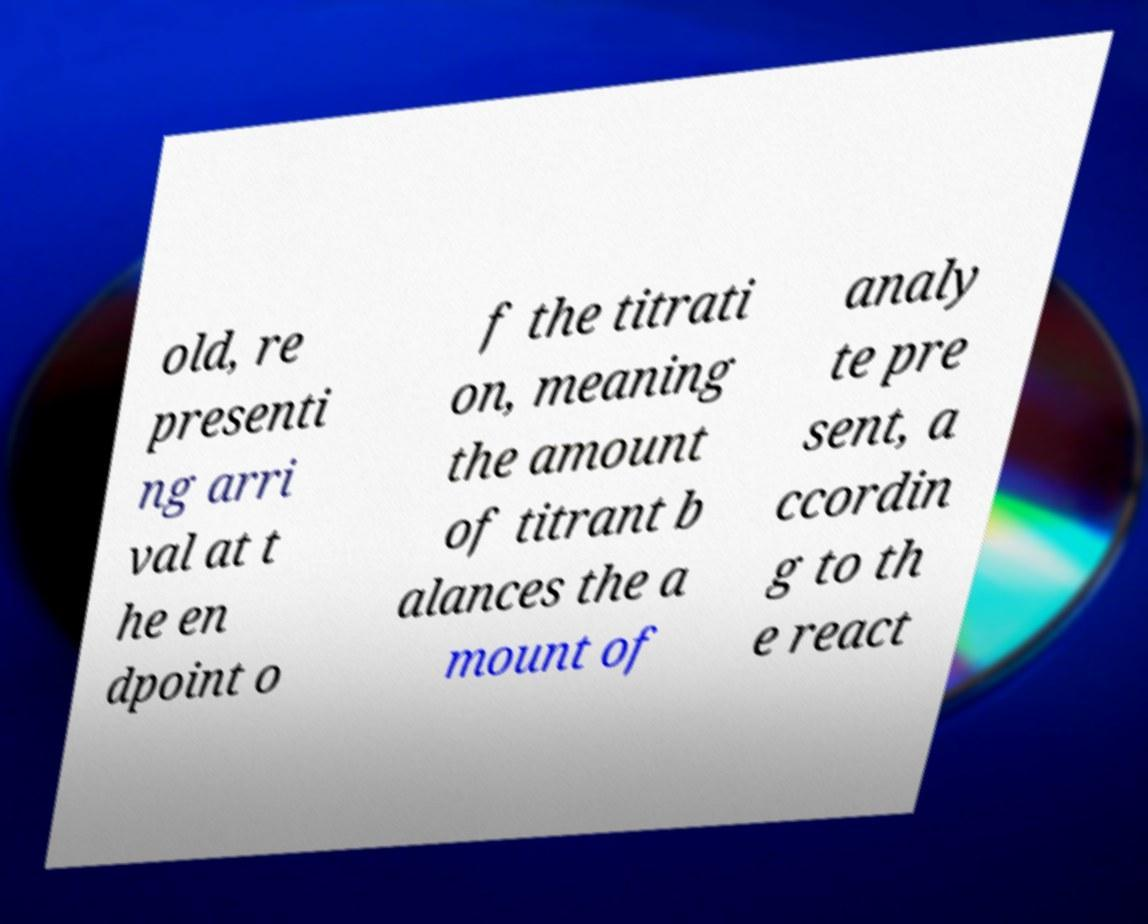Could you assist in decoding the text presented in this image and type it out clearly? old, re presenti ng arri val at t he en dpoint o f the titrati on, meaning the amount of titrant b alances the a mount of analy te pre sent, a ccordin g to th e react 